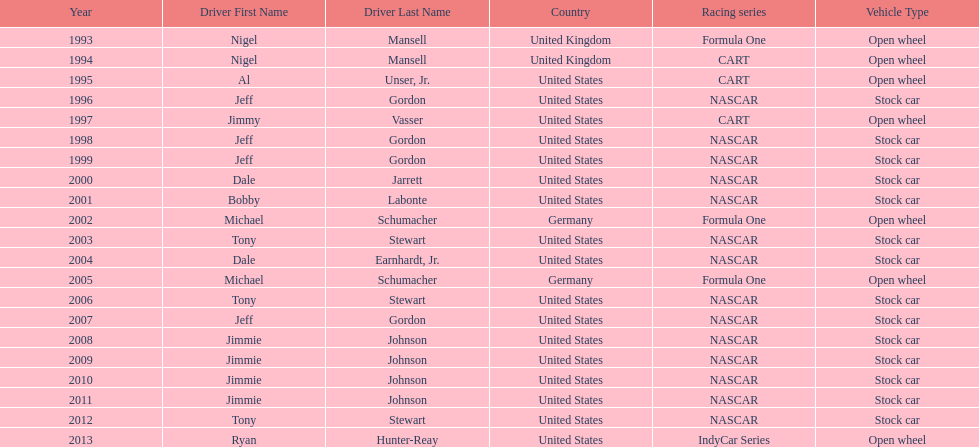Which driver won espy awards 11 years apart from each other? Jeff Gordon. 